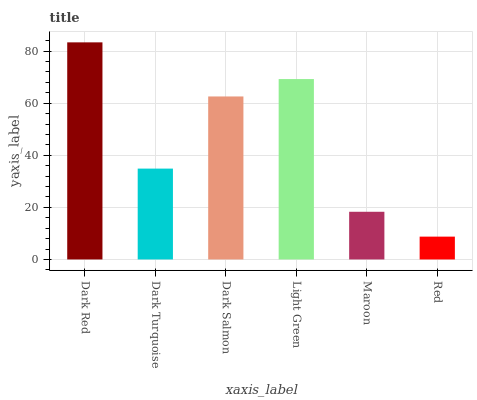Is Red the minimum?
Answer yes or no. Yes. Is Dark Red the maximum?
Answer yes or no. Yes. Is Dark Turquoise the minimum?
Answer yes or no. No. Is Dark Turquoise the maximum?
Answer yes or no. No. Is Dark Red greater than Dark Turquoise?
Answer yes or no. Yes. Is Dark Turquoise less than Dark Red?
Answer yes or no. Yes. Is Dark Turquoise greater than Dark Red?
Answer yes or no. No. Is Dark Red less than Dark Turquoise?
Answer yes or no. No. Is Dark Salmon the high median?
Answer yes or no. Yes. Is Dark Turquoise the low median?
Answer yes or no. Yes. Is Dark Turquoise the high median?
Answer yes or no. No. Is Light Green the low median?
Answer yes or no. No. 